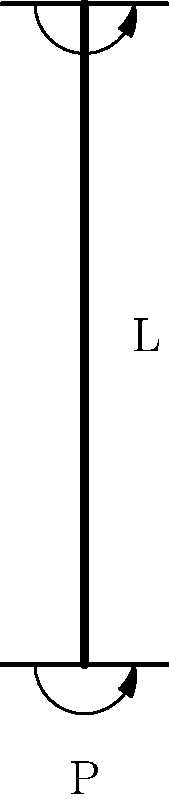Consider a column with pinned-pinned end conditions as shown in the figure. The column has a length $L$, elastic modulus $E$, and moment of inertia $I$. What is the critical buckling load $P_{cr}$ for this column? How would this load change if one end was fixed and the other remained pinned? To determine the critical buckling load for the column, we'll follow these steps:

1. For a pinned-pinned column (as shown in the figure), the critical buckling load is given by the Euler buckling formula:

   $$P_{cr} = \frac{\pi^2 EI}{L^2}$$

   Where:
   - $E$ is the elastic modulus
   - $I$ is the moment of inertia
   - $L$ is the length of the column

2. For a column with one end fixed and one end pinned (not shown in the figure), the effective length factor changes. The critical buckling load becomes:

   $$P_{cr} = \frac{\pi^2 EI}{(0.7L)^2} \approx 2.05 \frac{\pi^2 EI}{L^2}$$

3. Comparing the two cases:
   - Pinned-pinned: $P_{cr} = \frac{\pi^2 EI}{L^2}$
   - Fixed-pinned: $P_{cr} \approx 2.05 \frac{\pi^2 EI}{L^2}$

4. We can see that the fixed-pinned condition increases the critical buckling load by a factor of approximately 2.05 compared to the pinned-pinned condition.

This increase in critical buckling load is due to the increased stiffness provided by the fixed end, which reduces the effective length of the column for buckling purposes.
Answer: Pinned-pinned: $P_{cr} = \frac{\pi^2 EI}{L^2}$. Fixed-pinned: $P_{cr} \approx 2.05 \frac{\pi^2 EI}{L^2}$, about 2.05 times higher. 